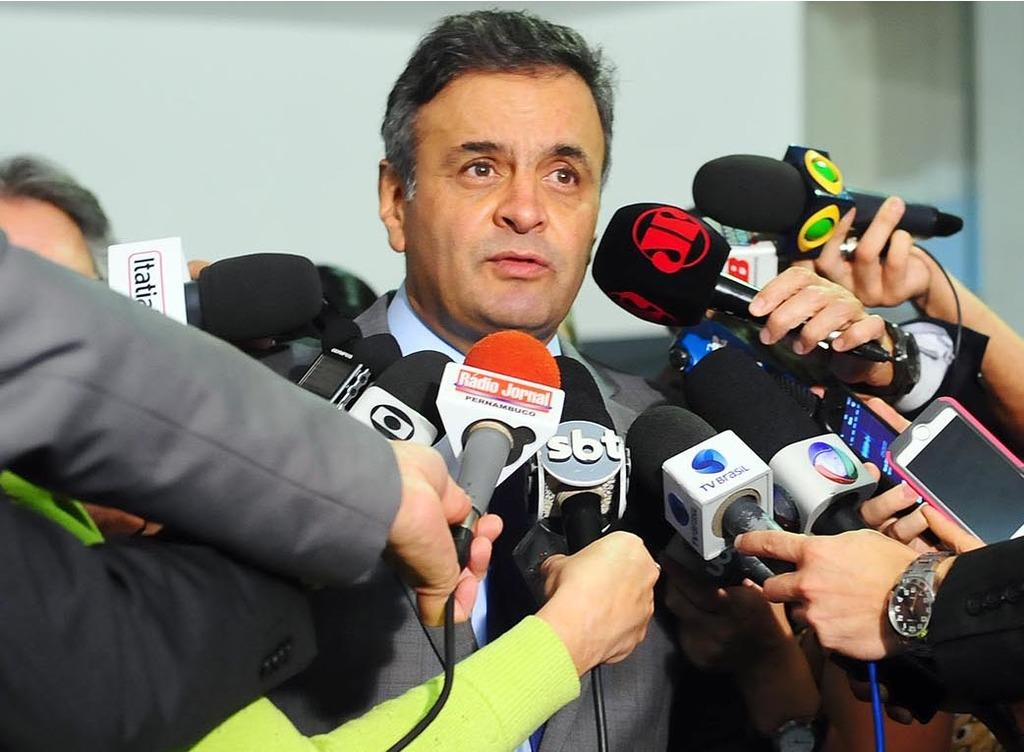Who or what is the main subject in the image? There is a person in the image. What is surrounding the person in the image? There are mics around the person. Can you identify any other objects in the image? Yes, there is a phone visible in the image. How many bees can be seen buzzing around the person in the image? There are no bees present in the image; it only features a person, mics, and a phone. 